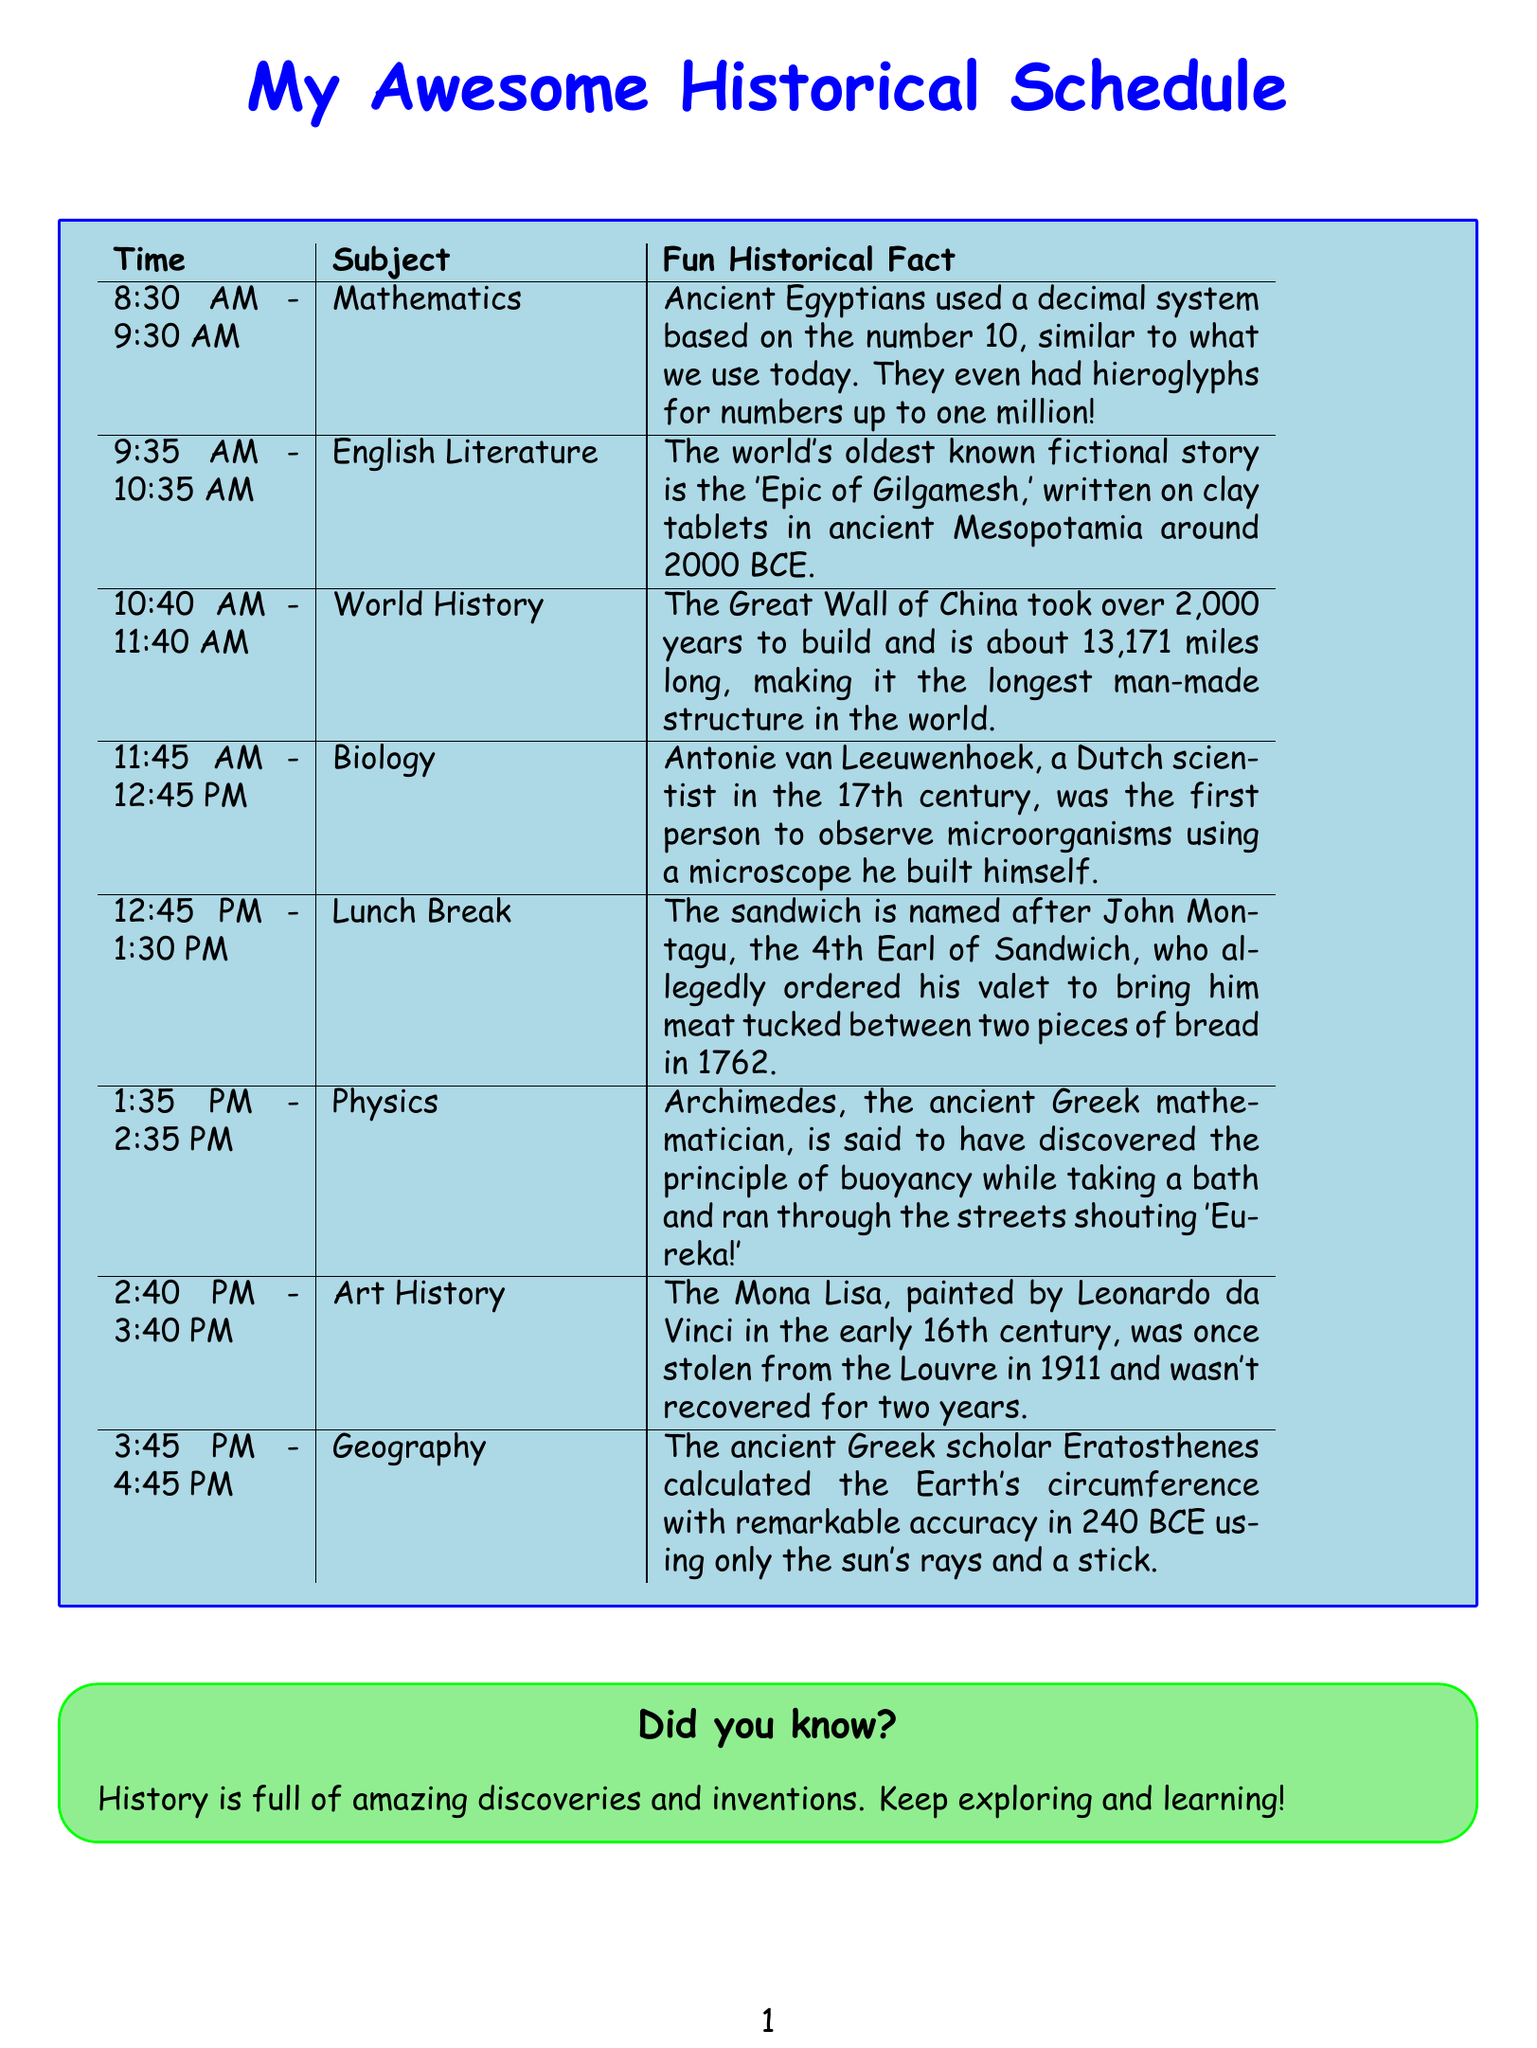What is the first subject of the day? The first subject can be found in the first row of the schedule, which lists the subject for the 8:30 AM time slot.
Answer: Mathematics What time does Lunch Break start? Lunch Break is listed in the schedule with its corresponding time slot beginning at 12:45 PM.
Answer: 12:45 PM Who painted the Mona Lisa? The fun fact about Art History states that the Mona Lisa was painted by Leonardo da Vinci.
Answer: Leonardo da Vinci How many years did it take to build the Great Wall of China? The schedule mentions that the Great Wall took over 2,000 years to build as part of the World History subject.
Answer: 2000 years Which scientist first observed microorganisms? The Biology section reveals that Antonie van Leeuwenhoek was the first to observe microorganisms using a microscope.
Answer: Antonie van Leeuwenhoek What historical event is associated with Archimedes? The Physics fun fact refers to Archimedes discovering buoyancy while taking a bath and shouting "Eureka!"
Answer: Eureka! What is the main historical structure mentioned in the World History subject? The schedule specifically mentions the Great Wall of China as the main historical structure in the World History section.
Answer: Great Wall of China What unique feature does the document highlight after the schedule? The document includes a section that emphasizes the importance of exploration and learning about history.
Answer: Did you know? 